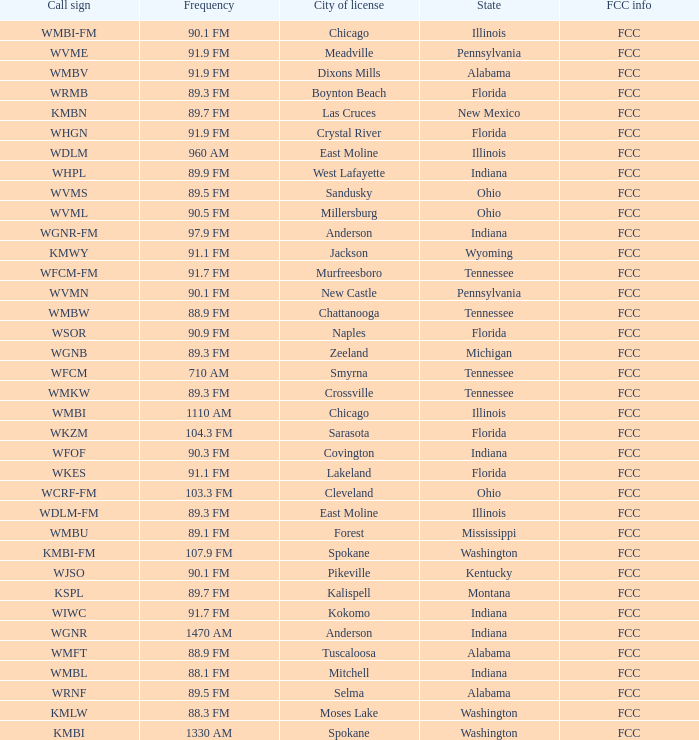What is the FCC info for the radio station in West Lafayette, Indiana? FCC. 